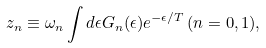Convert formula to latex. <formula><loc_0><loc_0><loc_500><loc_500>z _ { n } \equiv \omega _ { n } \int d \epsilon G _ { n } ( \epsilon ) e ^ { - \epsilon / T } \, ( n = 0 , 1 ) ,</formula> 